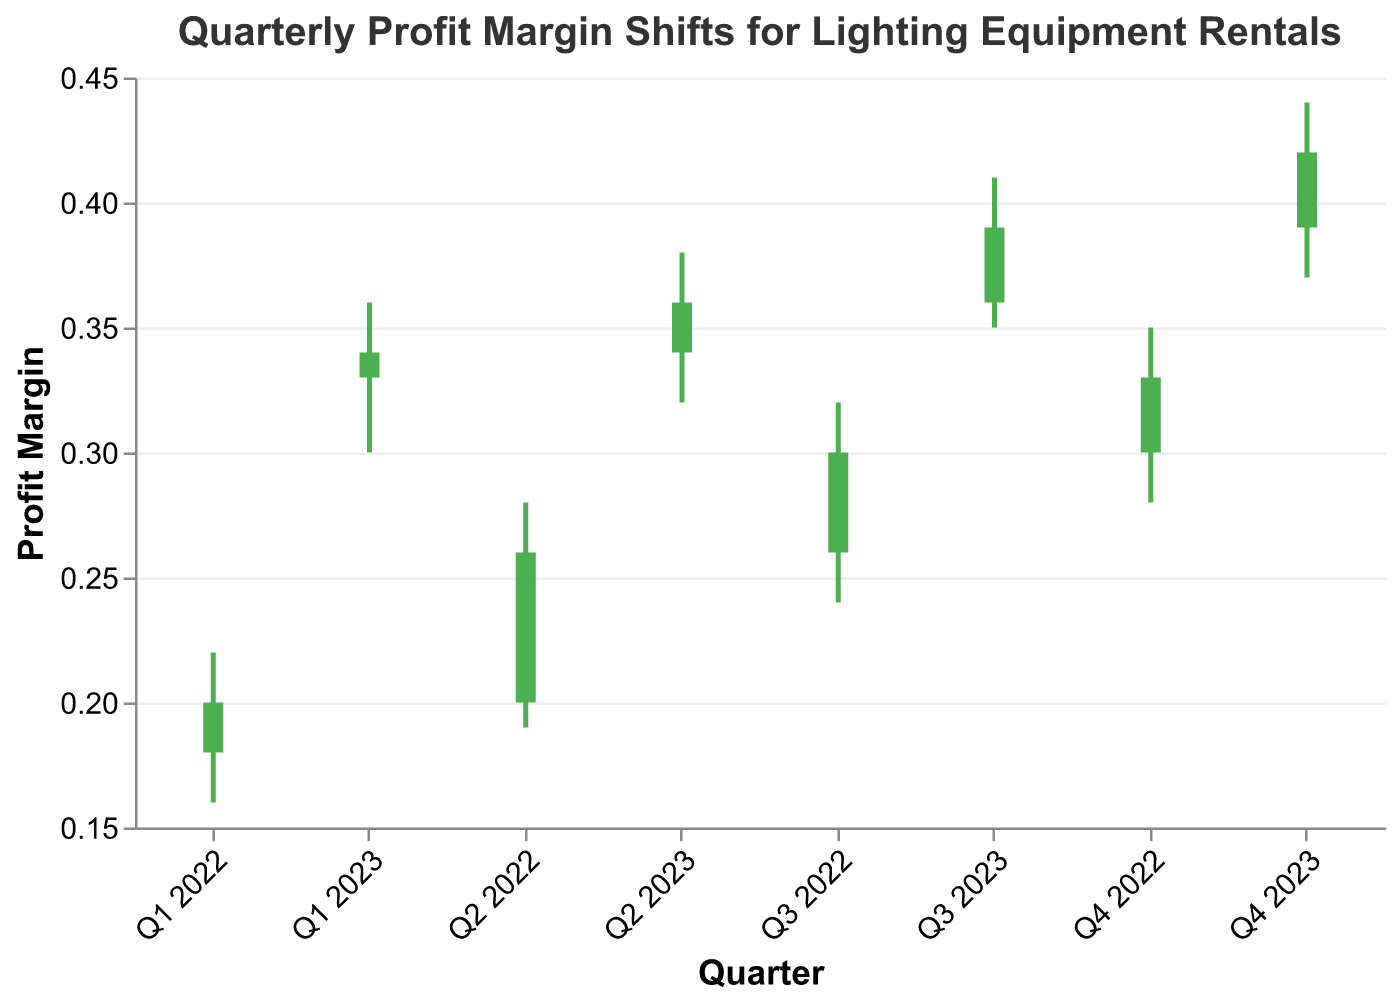what is the title of the chart? The title of the chart is located at the top of the figure. It indicates the main subject of the visualization.
Answer: Quarterly Profit Margin Shifts for Lighting Equipment Rentals How many quarters are displayed in the chart? The x-axis represents the quarters, and counting the distinct labels on the x-axis will give the total number of quarters presented. There are eight quarters shown, from Q1 2022 to Q4 2023.
Answer: Eight Which quarter shows the highest profit margin range? The highest profit margin range can be identified by finding the quarter with the largest difference between the high and low values. Q4 2023 displays the highest range with a high of 0.44 and a low of 0.37, making the range 0.07.
Answer: Q4 2023 In which quarters did the profit margin increase over the previous quarter? A profit margin increase over the previous quarter is determined when the "Close" value of the current quarter is higher than the "Close" value of the previous quarter. Comparing the close values consecutively: from Q1 2022 to Q2 2022, Q2 2022 to Q3 2022, Q3 2022 to Q4 2022, Q4 2022 to Q1 2023, Q1 2023 to Q2 2023, Q2 2023 to Q3 2023, and Q3 2023 to Q4 2023. The quarters where the close values are higher than the previous close are Q2 2022, Q3 2022, Q4 2022, Q1 2023, Q2 2023, Q3 2023, and Q4 2023.
Answer: Q2 2022, Q3 2022, Q4 2022, Q1 2023, Q2 2023, Q3 2023, and Q4 2023 What is the profit margin for Q3 2023? The profit margin for a specific quarter is found at the "Close" value for that quarter. For Q3 2023, the "Close" value is 0.39.
Answer: 0.39 Which quarter had the smallest increase in profit margin? To identify the smallest increase in profit margin, subtract the "Open" from the "Close" value for each quarter and find the smallest positive difference. For Q1 2022: 0.20-0.18=0.02, Q2 2022: 0.26-0.20=0.06, Q3 2022: 0.30-0.26=0.04, Q4 2022: 0.33-0.30=0.03, Q1 2023: 0.34-0.33=0.01, Q2 2023: 0.36-0.34=0.02, Q3 2023: 0.39-0.36=0.03, Q4 2023: 0.42-0.39=0.03. The smallest increase is in Q1 2023.
Answer: Q1 2023 What is the trend of the profit margin from Q1 2022 to Q4 2023? The trend can be observed by looking at the "Close" values over the quarters from Q1 2022 to Q4 2023. The "Close" values show a steady increase across the periods, indicating a positive upward trend in profit margins.
Answer: Upward trend What is the largest single-quarter profit margin drop and in which quarter did it occur? To find the largest single-quarter drop, calculate the difference between the "High" and "Low" values for each quarter and identify the maximum value. The largest drop occurs in Q2 2022 where high=0.28 and low=0.19 (difference = 0.09).
Answer: 0.09 in Q2 2022 In which quarters was the closing profit margin higher than the opening profit margin? A closing profit margin higher than the opening is determined when the "Close" value is higher than the "Open" value. For every quarter: Q1 2022 (0.20>0.18), Q2 2022 (0.26>0.20), Q3 2022 (0.30>0.26), Q4 2022 (0.33>0.30), Q1 2023 (0.34>0.33), Q2 2023 (0.36>0.34), Q3 2023 (0.39>0.36), and Q4 2023 (0.42>0.39).
Answer: All quarters (Q1 2022 to Q4 2023) 